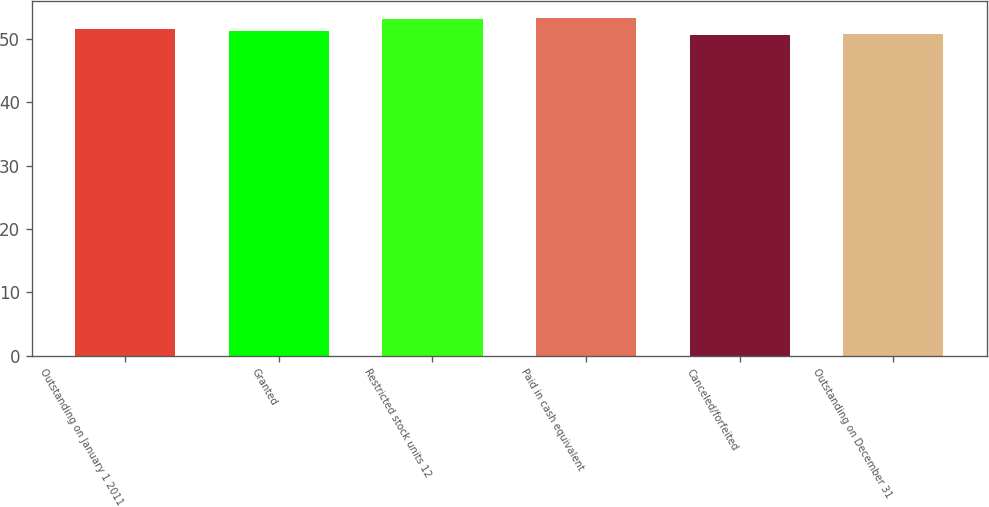Convert chart. <chart><loc_0><loc_0><loc_500><loc_500><bar_chart><fcel>Outstanding on January 1 2011<fcel>Granted<fcel>Restricted stock units 12<fcel>Paid in cash equivalent<fcel>Canceled/forfeited<fcel>Outstanding on December 31<nl><fcel>51.6<fcel>51.16<fcel>53.08<fcel>53.34<fcel>50.56<fcel>50.82<nl></chart> 